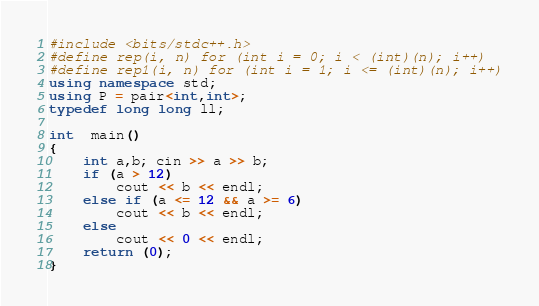Convert code to text. <code><loc_0><loc_0><loc_500><loc_500><_C++_>#include <bits/stdc++.h>
#define rep(i, n) for (int i = 0; i < (int)(n); i++)
#define rep1(i, n) for (int i = 1; i <= (int)(n); i++)
using namespace std;
using P = pair<int,int>;
typedef long long ll;

int  main()
{
	int a,b; cin >> a >> b;
	if (a > 12)
		cout << b << endl;
	else if (a <= 12 && a >= 6)
		cout << b << endl;
	else
		cout << 0 << endl;
	return (0);
}
</code> 